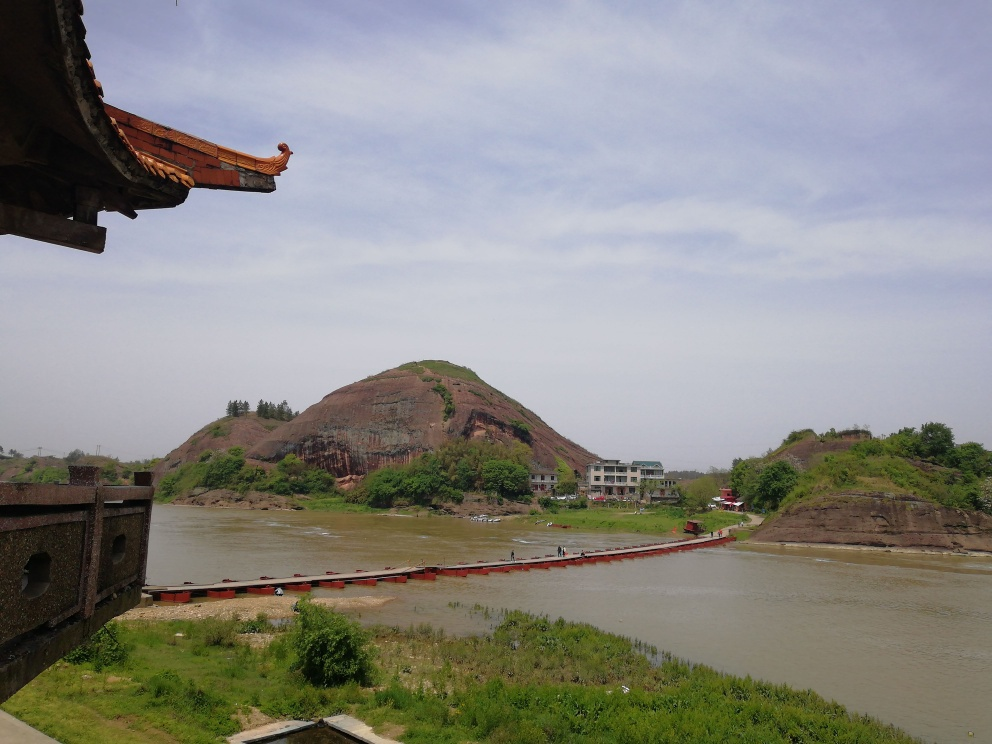Are there any specific flaws in this image? Based on the analysis of the image, it appears that there are no specific flaws in terms of visual quality or content errors. The image is clear, well-composed, and free from noticeable imperfections such as blurring, distortion, or unintended artifacts. 